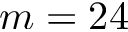Convert formula to latex. <formula><loc_0><loc_0><loc_500><loc_500>m = 2 4</formula> 